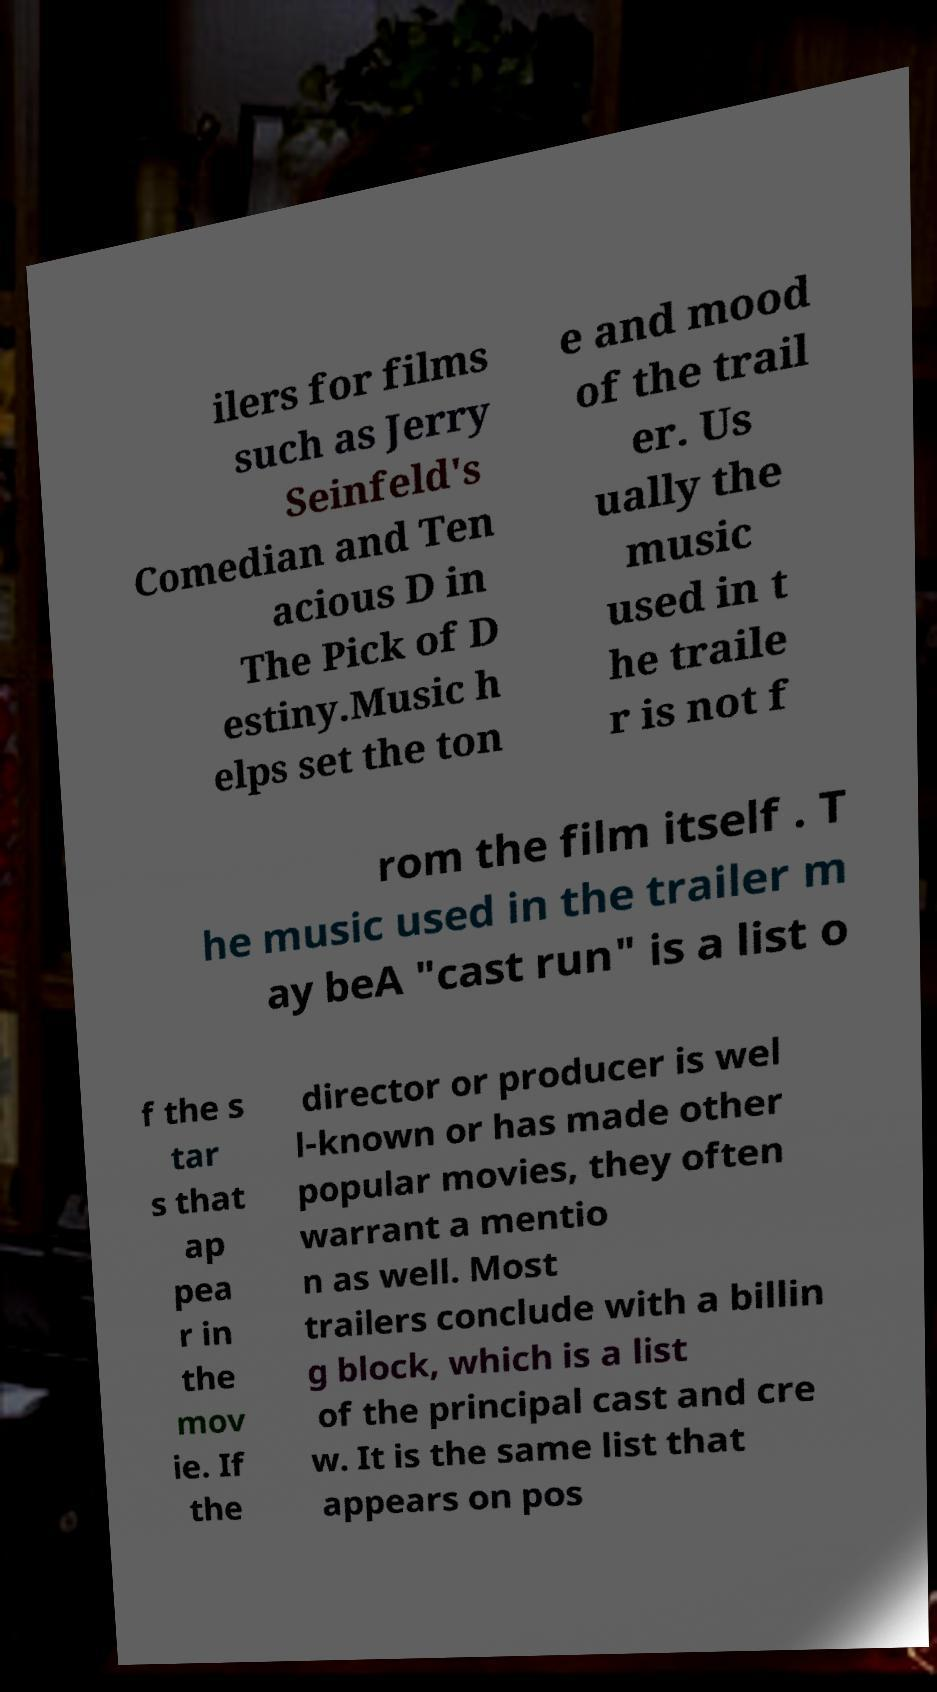There's text embedded in this image that I need extracted. Can you transcribe it verbatim? ilers for films such as Jerry Seinfeld's Comedian and Ten acious D in The Pick of D estiny.Music h elps set the ton e and mood of the trail er. Us ually the music used in t he traile r is not f rom the film itself . T he music used in the trailer m ay beA "cast run" is a list o f the s tar s that ap pea r in the mov ie. If the director or producer is wel l-known or has made other popular movies, they often warrant a mentio n as well. Most trailers conclude with a billin g block, which is a list of the principal cast and cre w. It is the same list that appears on pos 